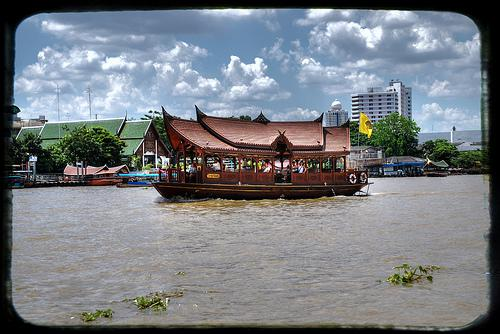Question: why is the water not clear?
Choices:
A. It is murky.
B. It is cloudy.
C. It is polluted.
D. It is dirty.
Answer with the letter. Answer: D Question: how is the weather?
Choices:
A. Clear and calm.
B. Rainy and stormy.
C. Sunny and hot.
D. Cold and windy.
Answer with the letter. Answer: A Question: what is floating on the water?
Choices:
A. Branches.
B. Leaves.
C. Debris.
D. Bottles.
Answer with the letter. Answer: A Question: who are in the photo?
Choices:
A. Children.
B. People.
C. Nuns.
D. Doctors.
Answer with the letter. Answer: B Question: where is the boat heading?
Choices:
A. North side.
B. East side.
C. South side.
D. West side.
Answer with the letter. Answer: D Question: what else is in the picture?
Choices:
A. A tall tree.
B. A white building.
C. A blue car.
D. A red fire hydrant.
Answer with the letter. Answer: B 